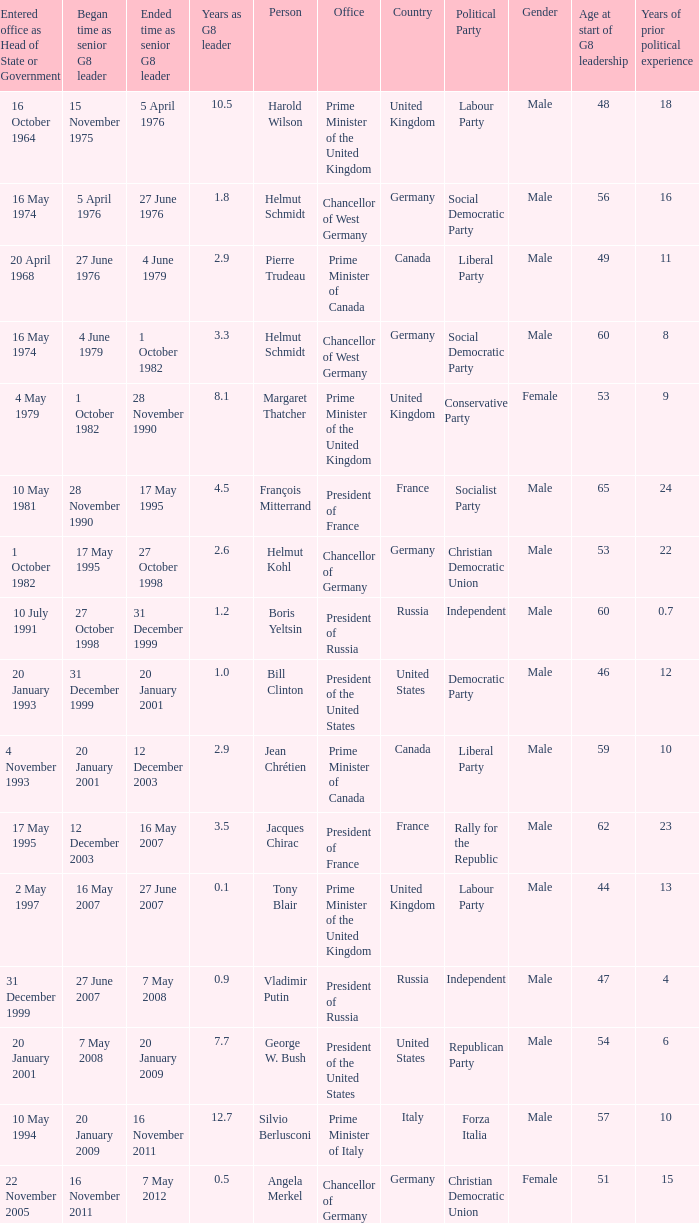When did Jacques Chirac stop being a G8 leader? 16 May 2007. 